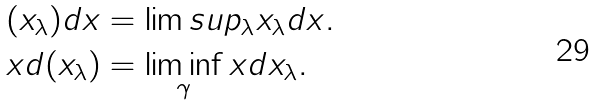<formula> <loc_0><loc_0><loc_500><loc_500>( x _ { \lambda } ) d x & = \lim s u p _ { \lambda } x _ { \lambda } d x . \\ x d ( x _ { \lambda } ) & = \liminf _ { \gamma } x d x _ { \lambda } .</formula> 